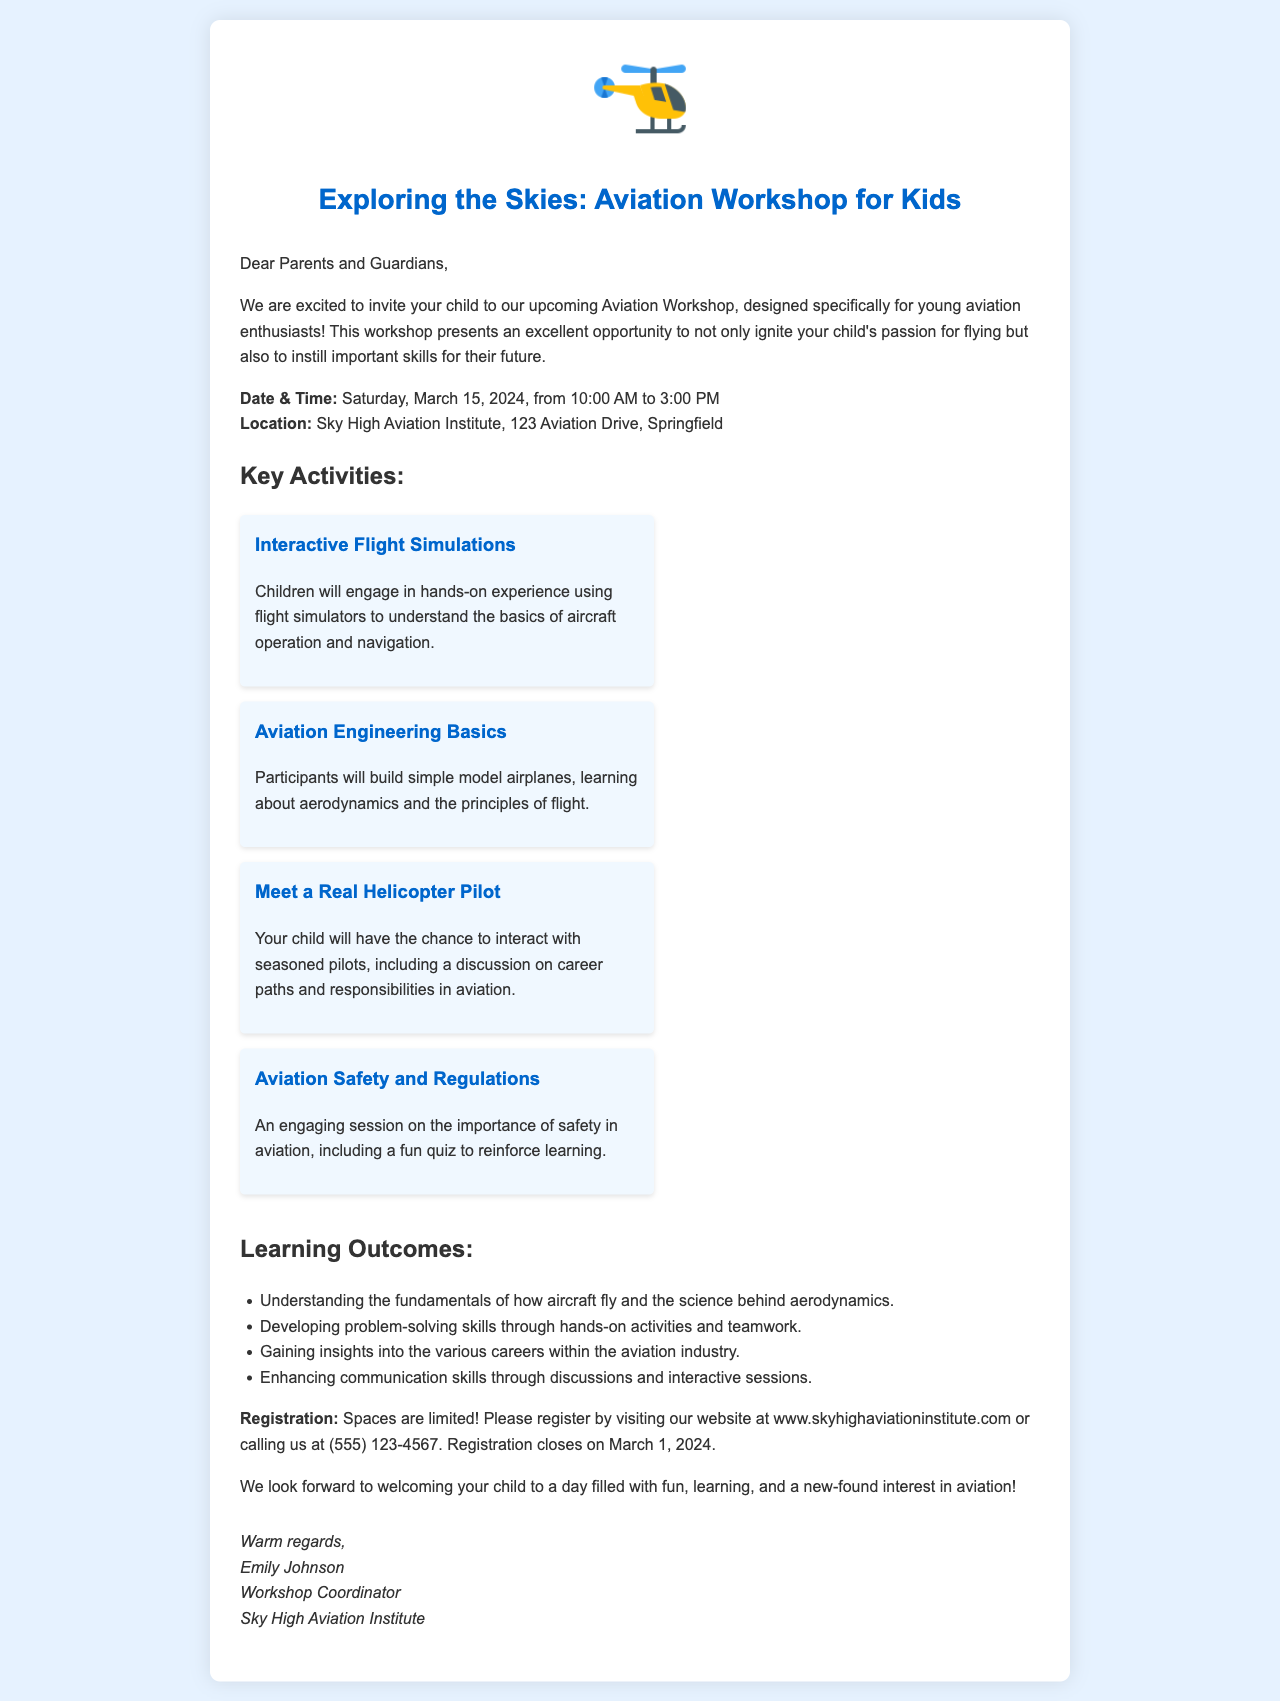what is the date of the workshop? The date of the workshop is clearly stated in the document as Saturday, March 15, 2024.
Answer: Saturday, March 15, 2024 where will the workshop be held? The document specifies the location of the workshop as Sky High Aviation Institute, 123 Aviation Drive, Springfield.
Answer: Sky High Aviation Institute, 123 Aviation Drive, Springfield what activity involves hands-on experience with flight simulators? The document mentions a specific activity called Interactive Flight Simulations that involves hands-on experience with flight simulators.
Answer: Interactive Flight Simulations who will children meet during the workshop? According to the workshop details, children will meet a real helicopter pilot during the event.
Answer: a real helicopter pilot what is the main focus of the Aviation Safety and Regulations session? The session on Aviation Safety and Regulations focuses on the importance of safety in aviation, including a fun quiz to reinforce learning.
Answer: importance of safety in aviation how many learning outcomes are listed in the document? The document lists a total of four learning outcomes that children can expect to achieve by participating in the workshop.
Answer: four when does registration close? The document states that registration closes on March 1, 2024.
Answer: March 1, 2024 what is the website for registration? The document provides the website for registration as www.skyhighaviationinstitute.com.
Answer: www.skyhighaviationinstitute.com who is the workshop coordinator? The signature section of the document identifies Emily Johnson as the workshop coordinator.
Answer: Emily Johnson 